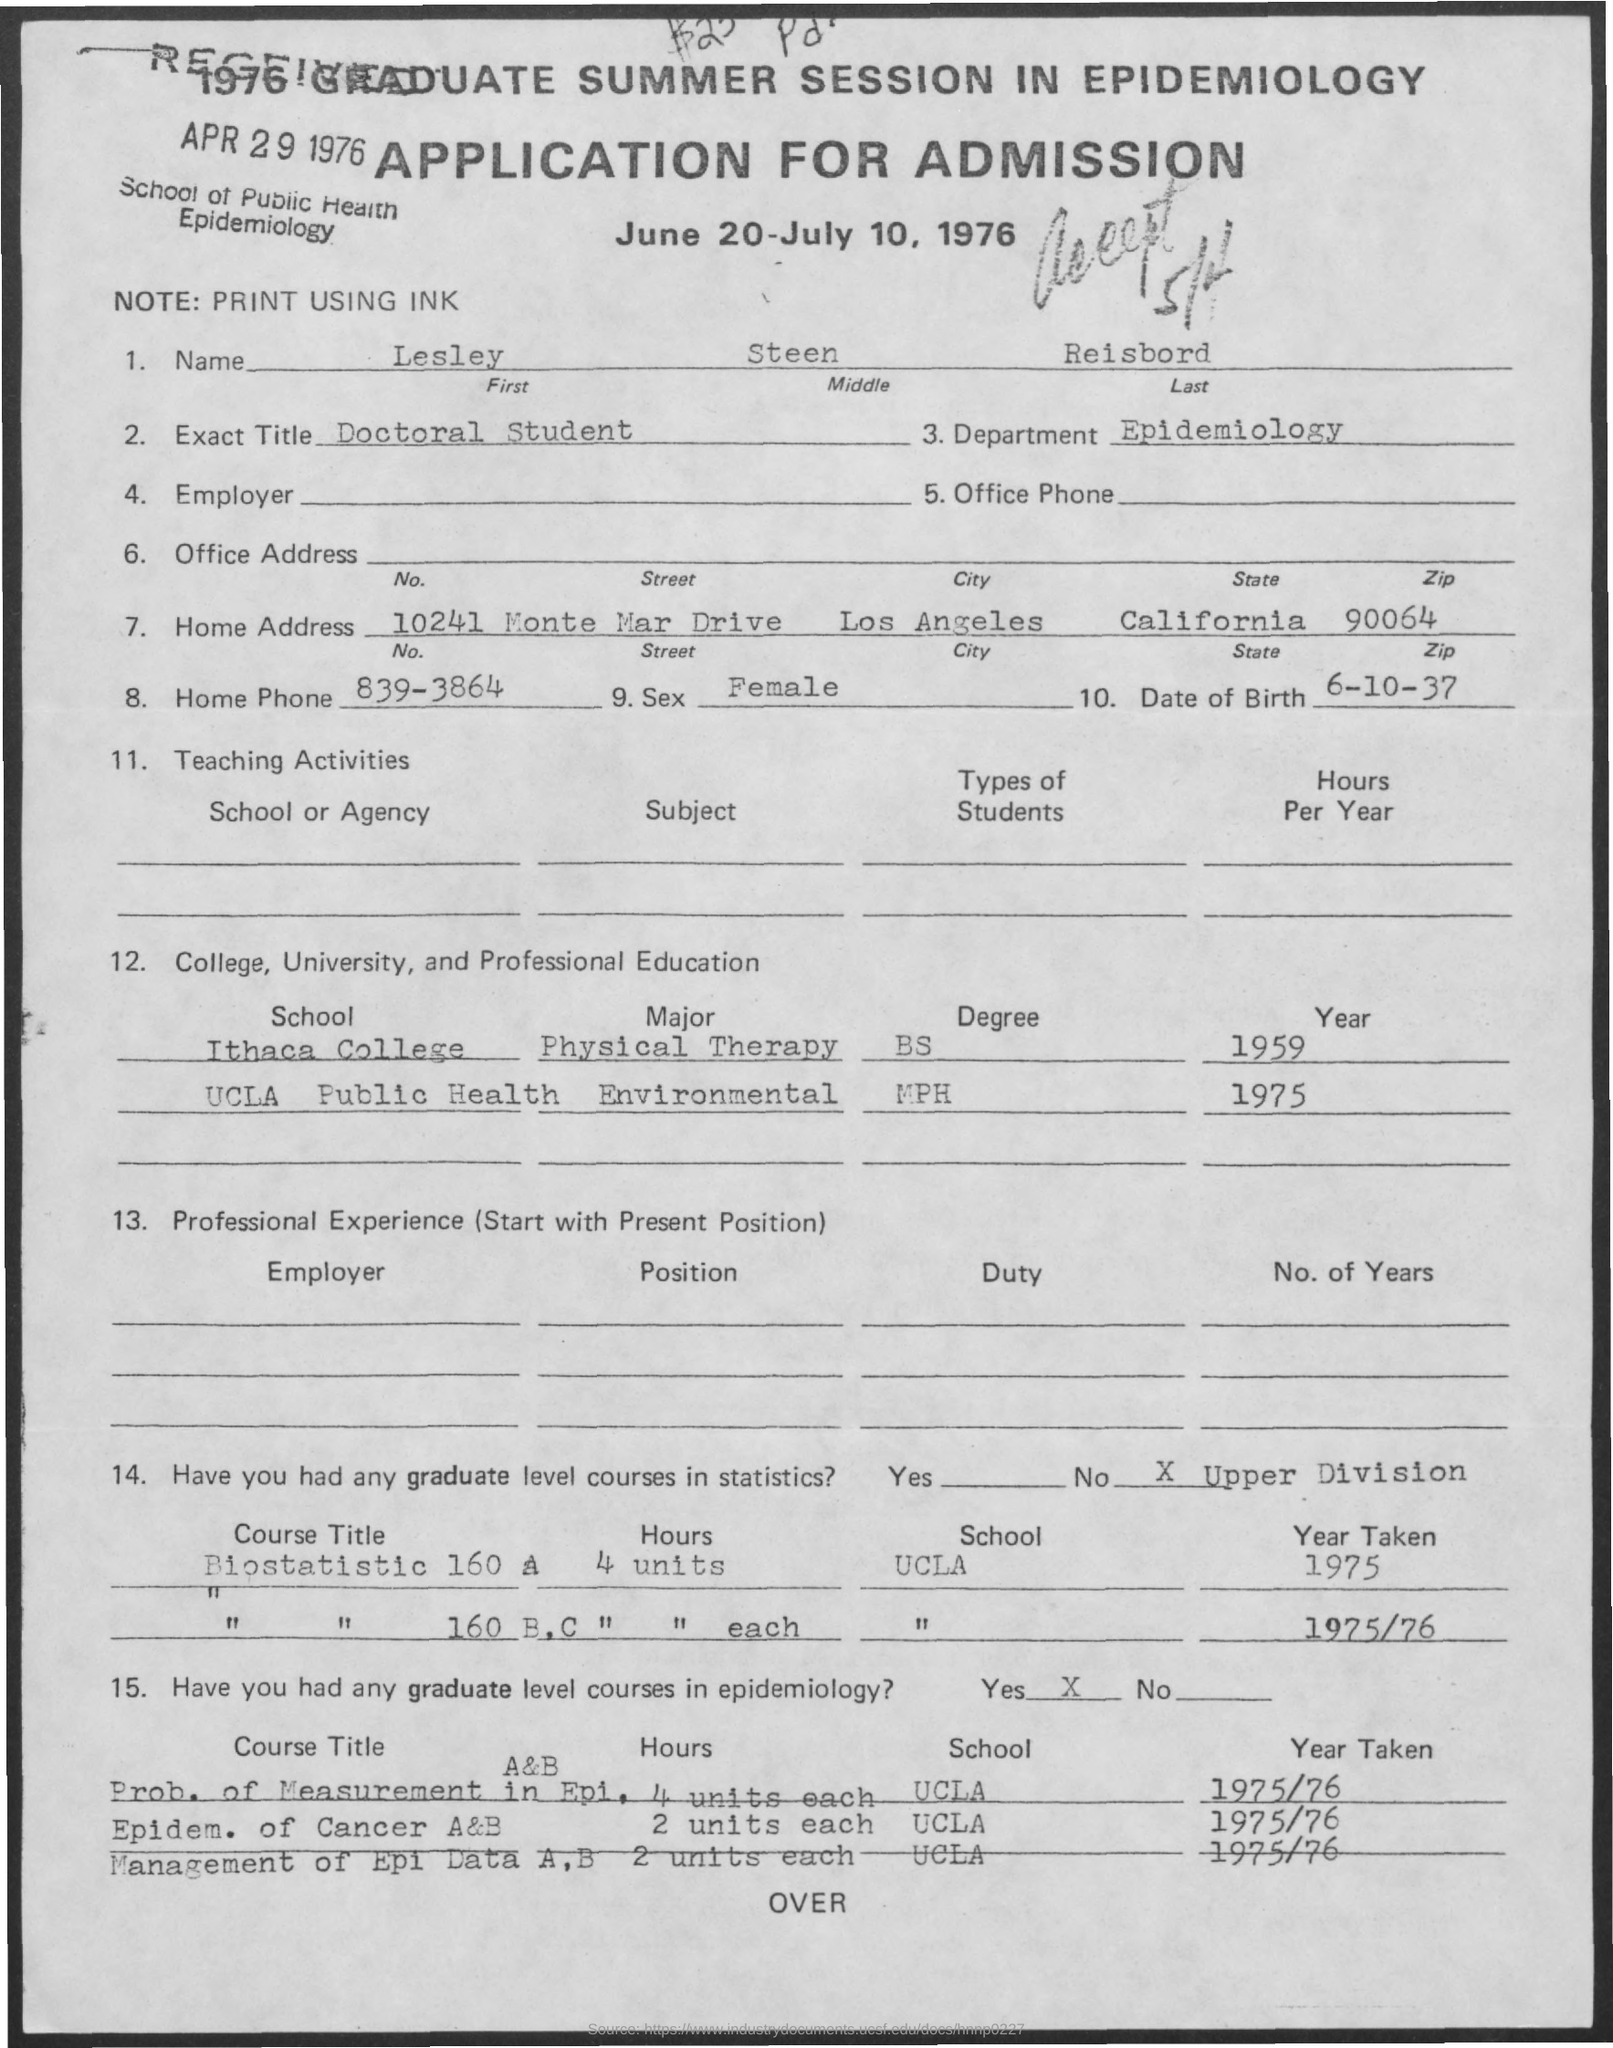Point out several critical features in this image. The last name mentioned in the given application is Reisbord. The middle name listed in the application is 'Steen.' The city mentioned in the home address is Los Angeles. The exact title mentioned in the given application is Doctoral Student. The date of birth mentioned in the given application is September 6, 1937. 